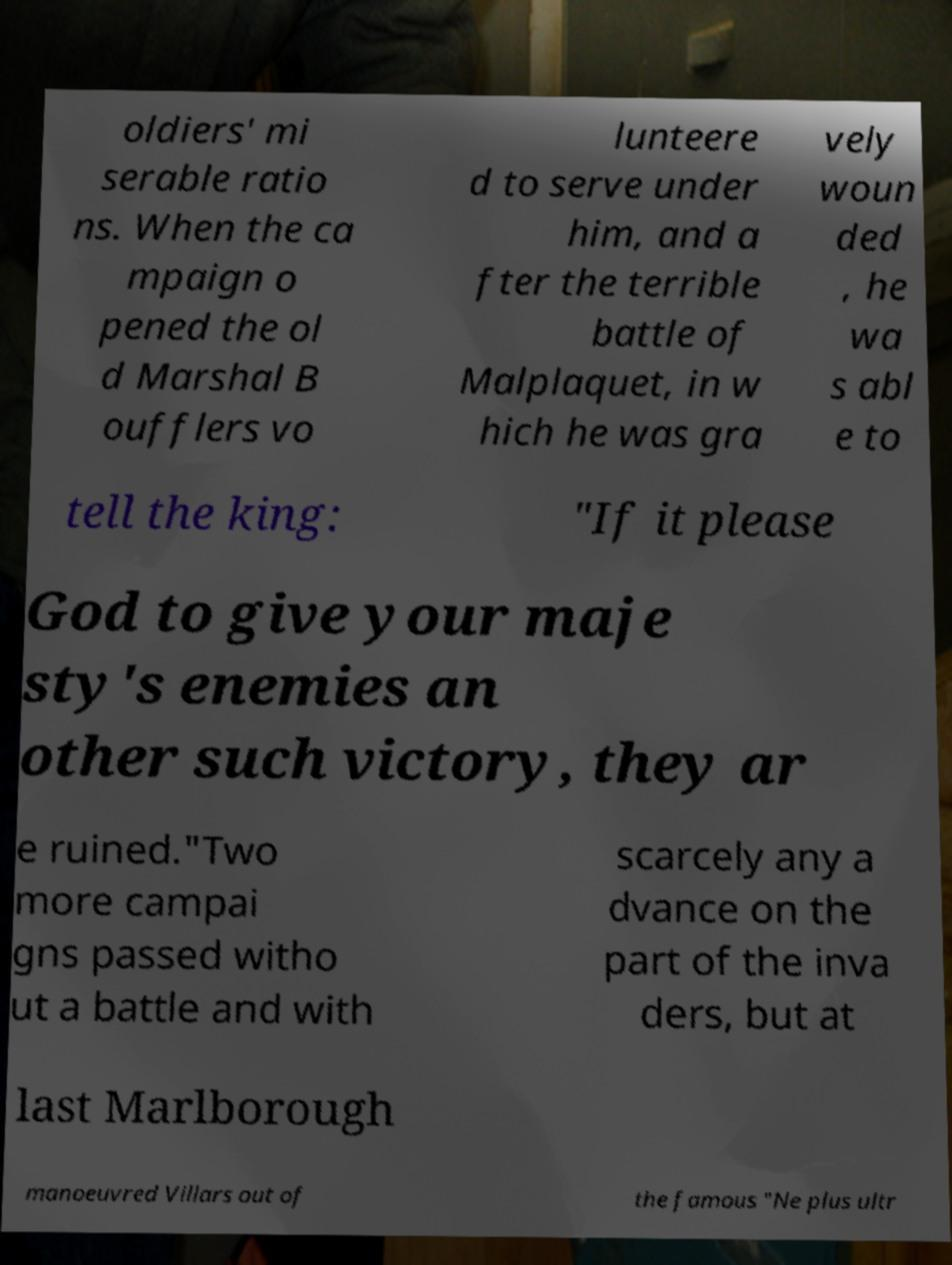There's text embedded in this image that I need extracted. Can you transcribe it verbatim? oldiers' mi serable ratio ns. When the ca mpaign o pened the ol d Marshal B oufflers vo lunteere d to serve under him, and a fter the terrible battle of Malplaquet, in w hich he was gra vely woun ded , he wa s abl e to tell the king: "If it please God to give your maje sty's enemies an other such victory, they ar e ruined."Two more campai gns passed witho ut a battle and with scarcely any a dvance on the part of the inva ders, but at last Marlborough manoeuvred Villars out of the famous "Ne plus ultr 